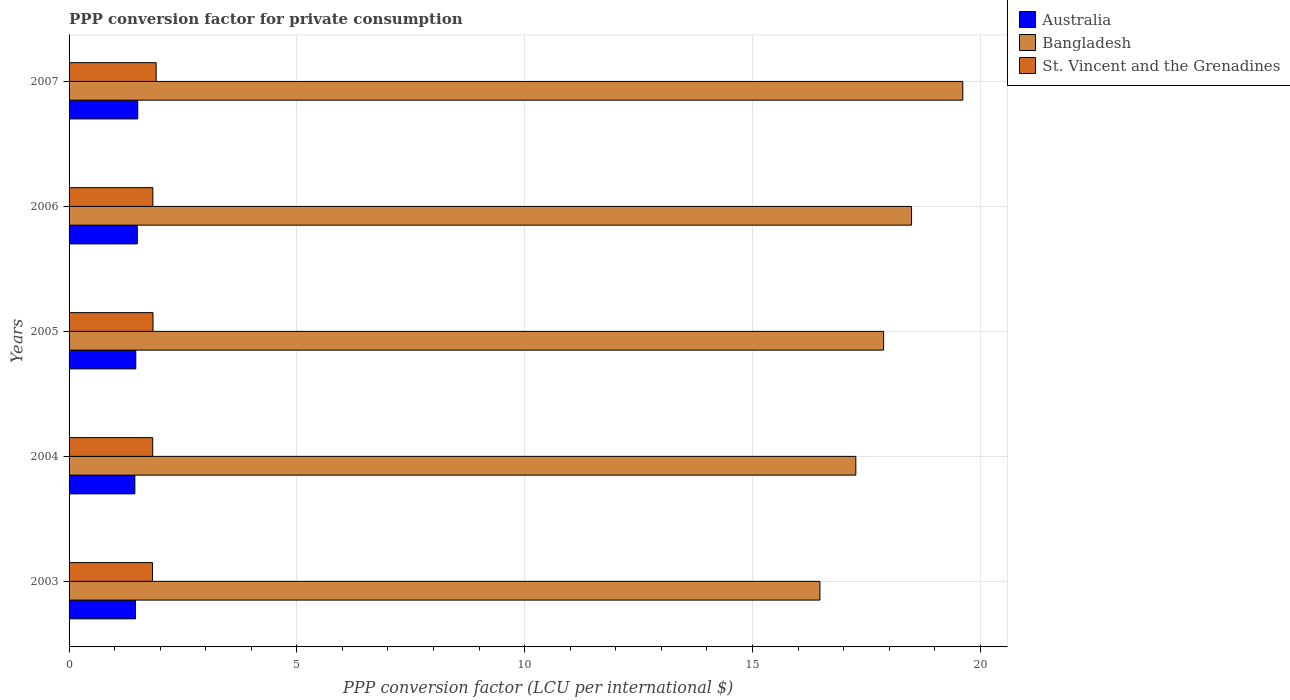How many different coloured bars are there?
Offer a very short reply. 3. How many groups of bars are there?
Your answer should be compact. 5. Are the number of bars on each tick of the Y-axis equal?
Make the answer very short. Yes. What is the label of the 2nd group of bars from the top?
Your response must be concise. 2006. In how many cases, is the number of bars for a given year not equal to the number of legend labels?
Offer a very short reply. 0. What is the PPP conversion factor for private consumption in St. Vincent and the Grenadines in 2005?
Give a very brief answer. 1.84. Across all years, what is the maximum PPP conversion factor for private consumption in Bangladesh?
Ensure brevity in your answer.  19.62. Across all years, what is the minimum PPP conversion factor for private consumption in Australia?
Your answer should be compact. 1.44. In which year was the PPP conversion factor for private consumption in St. Vincent and the Grenadines minimum?
Give a very brief answer. 2003. What is the total PPP conversion factor for private consumption in St. Vincent and the Grenadines in the graph?
Provide a succinct answer. 9.26. What is the difference between the PPP conversion factor for private consumption in Australia in 2006 and that in 2007?
Provide a succinct answer. -0.01. What is the difference between the PPP conversion factor for private consumption in Bangladesh in 2007 and the PPP conversion factor for private consumption in St. Vincent and the Grenadines in 2003?
Provide a short and direct response. 17.79. What is the average PPP conversion factor for private consumption in Bangladesh per year?
Make the answer very short. 17.95. In the year 2006, what is the difference between the PPP conversion factor for private consumption in Bangladesh and PPP conversion factor for private consumption in St. Vincent and the Grenadines?
Offer a terse response. 16.65. What is the ratio of the PPP conversion factor for private consumption in Australia in 2003 to that in 2005?
Make the answer very short. 1. Is the difference between the PPP conversion factor for private consumption in Bangladesh in 2005 and 2006 greater than the difference between the PPP conversion factor for private consumption in St. Vincent and the Grenadines in 2005 and 2006?
Offer a terse response. No. What is the difference between the highest and the second highest PPP conversion factor for private consumption in Australia?
Your response must be concise. 0.01. What is the difference between the highest and the lowest PPP conversion factor for private consumption in St. Vincent and the Grenadines?
Your answer should be compact. 0.08. Is the sum of the PPP conversion factor for private consumption in Bangladesh in 2005 and 2007 greater than the maximum PPP conversion factor for private consumption in Australia across all years?
Provide a short and direct response. Yes. What does the 3rd bar from the bottom in 2003 represents?
Your answer should be compact. St. Vincent and the Grenadines. Is it the case that in every year, the sum of the PPP conversion factor for private consumption in Bangladesh and PPP conversion factor for private consumption in Australia is greater than the PPP conversion factor for private consumption in St. Vincent and the Grenadines?
Offer a terse response. Yes. How many bars are there?
Give a very brief answer. 15. Are all the bars in the graph horizontal?
Keep it short and to the point. Yes. How many years are there in the graph?
Your response must be concise. 5. Does the graph contain grids?
Your answer should be very brief. Yes. Where does the legend appear in the graph?
Your response must be concise. Top right. How many legend labels are there?
Provide a short and direct response. 3. How are the legend labels stacked?
Keep it short and to the point. Vertical. What is the title of the graph?
Offer a terse response. PPP conversion factor for private consumption. Does "Slovak Republic" appear as one of the legend labels in the graph?
Make the answer very short. No. What is the label or title of the X-axis?
Provide a short and direct response. PPP conversion factor (LCU per international $). What is the PPP conversion factor (LCU per international $) of Australia in 2003?
Your answer should be very brief. 1.46. What is the PPP conversion factor (LCU per international $) of Bangladesh in 2003?
Offer a very short reply. 16.48. What is the PPP conversion factor (LCU per international $) in St. Vincent and the Grenadines in 2003?
Offer a very short reply. 1.83. What is the PPP conversion factor (LCU per international $) in Australia in 2004?
Provide a succinct answer. 1.44. What is the PPP conversion factor (LCU per international $) of Bangladesh in 2004?
Your answer should be very brief. 17.27. What is the PPP conversion factor (LCU per international $) of St. Vincent and the Grenadines in 2004?
Provide a short and direct response. 1.84. What is the PPP conversion factor (LCU per international $) of Australia in 2005?
Ensure brevity in your answer.  1.46. What is the PPP conversion factor (LCU per international $) of Bangladesh in 2005?
Provide a short and direct response. 17.88. What is the PPP conversion factor (LCU per international $) in St. Vincent and the Grenadines in 2005?
Your answer should be compact. 1.84. What is the PPP conversion factor (LCU per international $) of Australia in 2006?
Your response must be concise. 1.5. What is the PPP conversion factor (LCU per international $) of Bangladesh in 2006?
Your answer should be compact. 18.49. What is the PPP conversion factor (LCU per international $) of St. Vincent and the Grenadines in 2006?
Provide a succinct answer. 1.84. What is the PPP conversion factor (LCU per international $) in Australia in 2007?
Your answer should be very brief. 1.51. What is the PPP conversion factor (LCU per international $) in Bangladesh in 2007?
Provide a succinct answer. 19.62. What is the PPP conversion factor (LCU per international $) of St. Vincent and the Grenadines in 2007?
Provide a succinct answer. 1.91. Across all years, what is the maximum PPP conversion factor (LCU per international $) of Australia?
Your response must be concise. 1.51. Across all years, what is the maximum PPP conversion factor (LCU per international $) in Bangladesh?
Make the answer very short. 19.62. Across all years, what is the maximum PPP conversion factor (LCU per international $) of St. Vincent and the Grenadines?
Ensure brevity in your answer.  1.91. Across all years, what is the minimum PPP conversion factor (LCU per international $) in Australia?
Ensure brevity in your answer.  1.44. Across all years, what is the minimum PPP conversion factor (LCU per international $) in Bangladesh?
Provide a short and direct response. 16.48. Across all years, what is the minimum PPP conversion factor (LCU per international $) of St. Vincent and the Grenadines?
Offer a very short reply. 1.83. What is the total PPP conversion factor (LCU per international $) of Australia in the graph?
Make the answer very short. 7.37. What is the total PPP conversion factor (LCU per international $) in Bangladesh in the graph?
Your answer should be compact. 89.74. What is the total PPP conversion factor (LCU per international $) in St. Vincent and the Grenadines in the graph?
Ensure brevity in your answer.  9.26. What is the difference between the PPP conversion factor (LCU per international $) of Australia in 2003 and that in 2004?
Offer a terse response. 0.01. What is the difference between the PPP conversion factor (LCU per international $) in Bangladesh in 2003 and that in 2004?
Provide a short and direct response. -0.79. What is the difference between the PPP conversion factor (LCU per international $) in St. Vincent and the Grenadines in 2003 and that in 2004?
Your answer should be compact. -0.01. What is the difference between the PPP conversion factor (LCU per international $) in Australia in 2003 and that in 2005?
Your answer should be compact. -0.01. What is the difference between the PPP conversion factor (LCU per international $) in Bangladesh in 2003 and that in 2005?
Give a very brief answer. -1.4. What is the difference between the PPP conversion factor (LCU per international $) of St. Vincent and the Grenadines in 2003 and that in 2005?
Your answer should be compact. -0.01. What is the difference between the PPP conversion factor (LCU per international $) of Australia in 2003 and that in 2006?
Provide a short and direct response. -0.04. What is the difference between the PPP conversion factor (LCU per international $) of Bangladesh in 2003 and that in 2006?
Offer a very short reply. -2.01. What is the difference between the PPP conversion factor (LCU per international $) in St. Vincent and the Grenadines in 2003 and that in 2006?
Offer a terse response. -0.01. What is the difference between the PPP conversion factor (LCU per international $) of Australia in 2003 and that in 2007?
Offer a terse response. -0.05. What is the difference between the PPP conversion factor (LCU per international $) of Bangladesh in 2003 and that in 2007?
Offer a very short reply. -3.14. What is the difference between the PPP conversion factor (LCU per international $) in St. Vincent and the Grenadines in 2003 and that in 2007?
Your answer should be compact. -0.08. What is the difference between the PPP conversion factor (LCU per international $) in Australia in 2004 and that in 2005?
Ensure brevity in your answer.  -0.02. What is the difference between the PPP conversion factor (LCU per international $) in Bangladesh in 2004 and that in 2005?
Keep it short and to the point. -0.61. What is the difference between the PPP conversion factor (LCU per international $) in St. Vincent and the Grenadines in 2004 and that in 2005?
Make the answer very short. -0.01. What is the difference between the PPP conversion factor (LCU per international $) of Australia in 2004 and that in 2006?
Provide a succinct answer. -0.05. What is the difference between the PPP conversion factor (LCU per international $) in Bangladesh in 2004 and that in 2006?
Provide a succinct answer. -1.22. What is the difference between the PPP conversion factor (LCU per international $) in St. Vincent and the Grenadines in 2004 and that in 2006?
Your answer should be compact. -0. What is the difference between the PPP conversion factor (LCU per international $) in Australia in 2004 and that in 2007?
Provide a short and direct response. -0.06. What is the difference between the PPP conversion factor (LCU per international $) in Bangladesh in 2004 and that in 2007?
Your response must be concise. -2.35. What is the difference between the PPP conversion factor (LCU per international $) in St. Vincent and the Grenadines in 2004 and that in 2007?
Offer a terse response. -0.08. What is the difference between the PPP conversion factor (LCU per international $) in Australia in 2005 and that in 2006?
Ensure brevity in your answer.  -0.03. What is the difference between the PPP conversion factor (LCU per international $) of Bangladesh in 2005 and that in 2006?
Provide a short and direct response. -0.61. What is the difference between the PPP conversion factor (LCU per international $) in St. Vincent and the Grenadines in 2005 and that in 2006?
Your response must be concise. 0. What is the difference between the PPP conversion factor (LCU per international $) in Australia in 2005 and that in 2007?
Your response must be concise. -0.04. What is the difference between the PPP conversion factor (LCU per international $) of Bangladesh in 2005 and that in 2007?
Offer a terse response. -1.74. What is the difference between the PPP conversion factor (LCU per international $) of St. Vincent and the Grenadines in 2005 and that in 2007?
Offer a terse response. -0.07. What is the difference between the PPP conversion factor (LCU per international $) of Australia in 2006 and that in 2007?
Give a very brief answer. -0.01. What is the difference between the PPP conversion factor (LCU per international $) in Bangladesh in 2006 and that in 2007?
Offer a very short reply. -1.12. What is the difference between the PPP conversion factor (LCU per international $) of St. Vincent and the Grenadines in 2006 and that in 2007?
Keep it short and to the point. -0.07. What is the difference between the PPP conversion factor (LCU per international $) of Australia in 2003 and the PPP conversion factor (LCU per international $) of Bangladesh in 2004?
Make the answer very short. -15.81. What is the difference between the PPP conversion factor (LCU per international $) in Australia in 2003 and the PPP conversion factor (LCU per international $) in St. Vincent and the Grenadines in 2004?
Offer a very short reply. -0.38. What is the difference between the PPP conversion factor (LCU per international $) in Bangladesh in 2003 and the PPP conversion factor (LCU per international $) in St. Vincent and the Grenadines in 2004?
Offer a very short reply. 14.64. What is the difference between the PPP conversion factor (LCU per international $) in Australia in 2003 and the PPP conversion factor (LCU per international $) in Bangladesh in 2005?
Ensure brevity in your answer.  -16.42. What is the difference between the PPP conversion factor (LCU per international $) in Australia in 2003 and the PPP conversion factor (LCU per international $) in St. Vincent and the Grenadines in 2005?
Provide a succinct answer. -0.38. What is the difference between the PPP conversion factor (LCU per international $) in Bangladesh in 2003 and the PPP conversion factor (LCU per international $) in St. Vincent and the Grenadines in 2005?
Your answer should be very brief. 14.64. What is the difference between the PPP conversion factor (LCU per international $) in Australia in 2003 and the PPP conversion factor (LCU per international $) in Bangladesh in 2006?
Give a very brief answer. -17.03. What is the difference between the PPP conversion factor (LCU per international $) in Australia in 2003 and the PPP conversion factor (LCU per international $) in St. Vincent and the Grenadines in 2006?
Provide a succinct answer. -0.38. What is the difference between the PPP conversion factor (LCU per international $) of Bangladesh in 2003 and the PPP conversion factor (LCU per international $) of St. Vincent and the Grenadines in 2006?
Offer a very short reply. 14.64. What is the difference between the PPP conversion factor (LCU per international $) of Australia in 2003 and the PPP conversion factor (LCU per international $) of Bangladesh in 2007?
Make the answer very short. -18.16. What is the difference between the PPP conversion factor (LCU per international $) of Australia in 2003 and the PPP conversion factor (LCU per international $) of St. Vincent and the Grenadines in 2007?
Keep it short and to the point. -0.45. What is the difference between the PPP conversion factor (LCU per international $) of Bangladesh in 2003 and the PPP conversion factor (LCU per international $) of St. Vincent and the Grenadines in 2007?
Ensure brevity in your answer.  14.57. What is the difference between the PPP conversion factor (LCU per international $) of Australia in 2004 and the PPP conversion factor (LCU per international $) of Bangladesh in 2005?
Provide a succinct answer. -16.43. What is the difference between the PPP conversion factor (LCU per international $) of Australia in 2004 and the PPP conversion factor (LCU per international $) of St. Vincent and the Grenadines in 2005?
Offer a very short reply. -0.4. What is the difference between the PPP conversion factor (LCU per international $) in Bangladesh in 2004 and the PPP conversion factor (LCU per international $) in St. Vincent and the Grenadines in 2005?
Offer a very short reply. 15.43. What is the difference between the PPP conversion factor (LCU per international $) in Australia in 2004 and the PPP conversion factor (LCU per international $) in Bangladesh in 2006?
Your response must be concise. -17.05. What is the difference between the PPP conversion factor (LCU per international $) in Australia in 2004 and the PPP conversion factor (LCU per international $) in St. Vincent and the Grenadines in 2006?
Keep it short and to the point. -0.39. What is the difference between the PPP conversion factor (LCU per international $) in Bangladesh in 2004 and the PPP conversion factor (LCU per international $) in St. Vincent and the Grenadines in 2006?
Your response must be concise. 15.43. What is the difference between the PPP conversion factor (LCU per international $) of Australia in 2004 and the PPP conversion factor (LCU per international $) of Bangladesh in 2007?
Ensure brevity in your answer.  -18.17. What is the difference between the PPP conversion factor (LCU per international $) of Australia in 2004 and the PPP conversion factor (LCU per international $) of St. Vincent and the Grenadines in 2007?
Keep it short and to the point. -0.47. What is the difference between the PPP conversion factor (LCU per international $) of Bangladesh in 2004 and the PPP conversion factor (LCU per international $) of St. Vincent and the Grenadines in 2007?
Offer a very short reply. 15.36. What is the difference between the PPP conversion factor (LCU per international $) in Australia in 2005 and the PPP conversion factor (LCU per international $) in Bangladesh in 2006?
Give a very brief answer. -17.03. What is the difference between the PPP conversion factor (LCU per international $) in Australia in 2005 and the PPP conversion factor (LCU per international $) in St. Vincent and the Grenadines in 2006?
Keep it short and to the point. -0.37. What is the difference between the PPP conversion factor (LCU per international $) in Bangladesh in 2005 and the PPP conversion factor (LCU per international $) in St. Vincent and the Grenadines in 2006?
Give a very brief answer. 16.04. What is the difference between the PPP conversion factor (LCU per international $) in Australia in 2005 and the PPP conversion factor (LCU per international $) in Bangladesh in 2007?
Your answer should be very brief. -18.15. What is the difference between the PPP conversion factor (LCU per international $) of Australia in 2005 and the PPP conversion factor (LCU per international $) of St. Vincent and the Grenadines in 2007?
Provide a short and direct response. -0.45. What is the difference between the PPP conversion factor (LCU per international $) of Bangladesh in 2005 and the PPP conversion factor (LCU per international $) of St. Vincent and the Grenadines in 2007?
Offer a terse response. 15.97. What is the difference between the PPP conversion factor (LCU per international $) of Australia in 2006 and the PPP conversion factor (LCU per international $) of Bangladesh in 2007?
Provide a short and direct response. -18.12. What is the difference between the PPP conversion factor (LCU per international $) in Australia in 2006 and the PPP conversion factor (LCU per international $) in St. Vincent and the Grenadines in 2007?
Keep it short and to the point. -0.41. What is the difference between the PPP conversion factor (LCU per international $) in Bangladesh in 2006 and the PPP conversion factor (LCU per international $) in St. Vincent and the Grenadines in 2007?
Offer a very short reply. 16.58. What is the average PPP conversion factor (LCU per international $) in Australia per year?
Make the answer very short. 1.47. What is the average PPP conversion factor (LCU per international $) of Bangladesh per year?
Your response must be concise. 17.95. What is the average PPP conversion factor (LCU per international $) in St. Vincent and the Grenadines per year?
Ensure brevity in your answer.  1.85. In the year 2003, what is the difference between the PPP conversion factor (LCU per international $) of Australia and PPP conversion factor (LCU per international $) of Bangladesh?
Offer a very short reply. -15.02. In the year 2003, what is the difference between the PPP conversion factor (LCU per international $) of Australia and PPP conversion factor (LCU per international $) of St. Vincent and the Grenadines?
Make the answer very short. -0.37. In the year 2003, what is the difference between the PPP conversion factor (LCU per international $) of Bangladesh and PPP conversion factor (LCU per international $) of St. Vincent and the Grenadines?
Give a very brief answer. 14.65. In the year 2004, what is the difference between the PPP conversion factor (LCU per international $) in Australia and PPP conversion factor (LCU per international $) in Bangladesh?
Make the answer very short. -15.82. In the year 2004, what is the difference between the PPP conversion factor (LCU per international $) of Australia and PPP conversion factor (LCU per international $) of St. Vincent and the Grenadines?
Your response must be concise. -0.39. In the year 2004, what is the difference between the PPP conversion factor (LCU per international $) in Bangladesh and PPP conversion factor (LCU per international $) in St. Vincent and the Grenadines?
Make the answer very short. 15.43. In the year 2005, what is the difference between the PPP conversion factor (LCU per international $) in Australia and PPP conversion factor (LCU per international $) in Bangladesh?
Provide a succinct answer. -16.41. In the year 2005, what is the difference between the PPP conversion factor (LCU per international $) of Australia and PPP conversion factor (LCU per international $) of St. Vincent and the Grenadines?
Provide a short and direct response. -0.38. In the year 2005, what is the difference between the PPP conversion factor (LCU per international $) in Bangladesh and PPP conversion factor (LCU per international $) in St. Vincent and the Grenadines?
Provide a short and direct response. 16.04. In the year 2006, what is the difference between the PPP conversion factor (LCU per international $) in Australia and PPP conversion factor (LCU per international $) in Bangladesh?
Offer a terse response. -16.99. In the year 2006, what is the difference between the PPP conversion factor (LCU per international $) of Australia and PPP conversion factor (LCU per international $) of St. Vincent and the Grenadines?
Ensure brevity in your answer.  -0.34. In the year 2006, what is the difference between the PPP conversion factor (LCU per international $) in Bangladesh and PPP conversion factor (LCU per international $) in St. Vincent and the Grenadines?
Offer a terse response. 16.65. In the year 2007, what is the difference between the PPP conversion factor (LCU per international $) in Australia and PPP conversion factor (LCU per international $) in Bangladesh?
Give a very brief answer. -18.11. In the year 2007, what is the difference between the PPP conversion factor (LCU per international $) of Australia and PPP conversion factor (LCU per international $) of St. Vincent and the Grenadines?
Offer a very short reply. -0.4. In the year 2007, what is the difference between the PPP conversion factor (LCU per international $) of Bangladesh and PPP conversion factor (LCU per international $) of St. Vincent and the Grenadines?
Offer a very short reply. 17.7. What is the ratio of the PPP conversion factor (LCU per international $) in Australia in 2003 to that in 2004?
Provide a short and direct response. 1.01. What is the ratio of the PPP conversion factor (LCU per international $) of Bangladesh in 2003 to that in 2004?
Give a very brief answer. 0.95. What is the ratio of the PPP conversion factor (LCU per international $) in Bangladesh in 2003 to that in 2005?
Offer a terse response. 0.92. What is the ratio of the PPP conversion factor (LCU per international $) in Australia in 2003 to that in 2006?
Your answer should be compact. 0.97. What is the ratio of the PPP conversion factor (LCU per international $) of Bangladesh in 2003 to that in 2006?
Offer a terse response. 0.89. What is the ratio of the PPP conversion factor (LCU per international $) in St. Vincent and the Grenadines in 2003 to that in 2006?
Offer a terse response. 1. What is the ratio of the PPP conversion factor (LCU per international $) in Australia in 2003 to that in 2007?
Provide a succinct answer. 0.97. What is the ratio of the PPP conversion factor (LCU per international $) in Bangladesh in 2003 to that in 2007?
Keep it short and to the point. 0.84. What is the ratio of the PPP conversion factor (LCU per international $) in St. Vincent and the Grenadines in 2003 to that in 2007?
Give a very brief answer. 0.96. What is the ratio of the PPP conversion factor (LCU per international $) of Australia in 2004 to that in 2005?
Offer a very short reply. 0.99. What is the ratio of the PPP conversion factor (LCU per international $) in Bangladesh in 2004 to that in 2005?
Keep it short and to the point. 0.97. What is the ratio of the PPP conversion factor (LCU per international $) in St. Vincent and the Grenadines in 2004 to that in 2005?
Keep it short and to the point. 1. What is the ratio of the PPP conversion factor (LCU per international $) of Australia in 2004 to that in 2006?
Provide a succinct answer. 0.96. What is the ratio of the PPP conversion factor (LCU per international $) in Bangladesh in 2004 to that in 2006?
Provide a succinct answer. 0.93. What is the ratio of the PPP conversion factor (LCU per international $) of St. Vincent and the Grenadines in 2004 to that in 2006?
Your response must be concise. 1. What is the ratio of the PPP conversion factor (LCU per international $) of Australia in 2004 to that in 2007?
Keep it short and to the point. 0.96. What is the ratio of the PPP conversion factor (LCU per international $) in Bangladesh in 2004 to that in 2007?
Provide a succinct answer. 0.88. What is the ratio of the PPP conversion factor (LCU per international $) in St. Vincent and the Grenadines in 2004 to that in 2007?
Your response must be concise. 0.96. What is the ratio of the PPP conversion factor (LCU per international $) of Australia in 2005 to that in 2006?
Give a very brief answer. 0.98. What is the ratio of the PPP conversion factor (LCU per international $) in Bangladesh in 2005 to that in 2006?
Make the answer very short. 0.97. What is the ratio of the PPP conversion factor (LCU per international $) in Australia in 2005 to that in 2007?
Offer a very short reply. 0.97. What is the ratio of the PPP conversion factor (LCU per international $) of Bangladesh in 2005 to that in 2007?
Ensure brevity in your answer.  0.91. What is the ratio of the PPP conversion factor (LCU per international $) in St. Vincent and the Grenadines in 2005 to that in 2007?
Your response must be concise. 0.96. What is the ratio of the PPP conversion factor (LCU per international $) in Bangladesh in 2006 to that in 2007?
Your answer should be very brief. 0.94. What is the difference between the highest and the second highest PPP conversion factor (LCU per international $) of Australia?
Your answer should be compact. 0.01. What is the difference between the highest and the second highest PPP conversion factor (LCU per international $) of Bangladesh?
Give a very brief answer. 1.12. What is the difference between the highest and the second highest PPP conversion factor (LCU per international $) in St. Vincent and the Grenadines?
Provide a short and direct response. 0.07. What is the difference between the highest and the lowest PPP conversion factor (LCU per international $) in Australia?
Make the answer very short. 0.06. What is the difference between the highest and the lowest PPP conversion factor (LCU per international $) of Bangladesh?
Provide a short and direct response. 3.14. What is the difference between the highest and the lowest PPP conversion factor (LCU per international $) in St. Vincent and the Grenadines?
Provide a succinct answer. 0.08. 